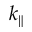<formula> <loc_0><loc_0><loc_500><loc_500>k _ { \| }</formula> 